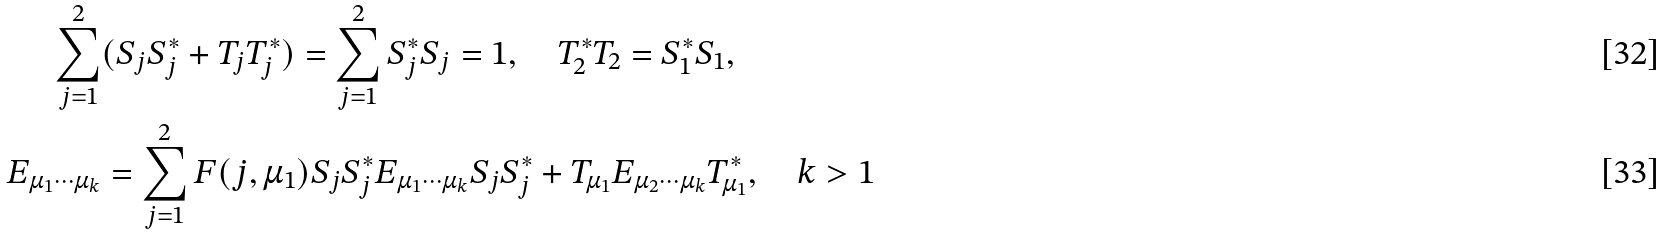Convert formula to latex. <formula><loc_0><loc_0><loc_500><loc_500>\sum _ { j = 1 } ^ { 2 } & ( S _ { j } S _ { j } ^ { * } + T _ { j } T _ { j } ^ { * } ) = \sum _ { j = 1 } ^ { 2 } S _ { j } ^ { * } S _ { j } = 1 , \quad T _ { 2 } ^ { * } T _ { 2 } = S _ { 1 } ^ { * } S _ { 1 } , \\ E _ { \mu _ { 1 } \cdots \mu _ { k } } & = \sum _ { j = 1 } ^ { 2 } F ( j , \mu _ { 1 } ) S _ { j } S _ { j } ^ { * } E _ { \mu _ { 1 } \cdots \mu _ { k } } S _ { j } S _ { j } ^ { * } + T _ { \mu _ { 1 } } E _ { \mu _ { 2 } \cdots \mu _ { k } } T _ { \mu _ { 1 } } ^ { * } , \quad k > 1</formula> 